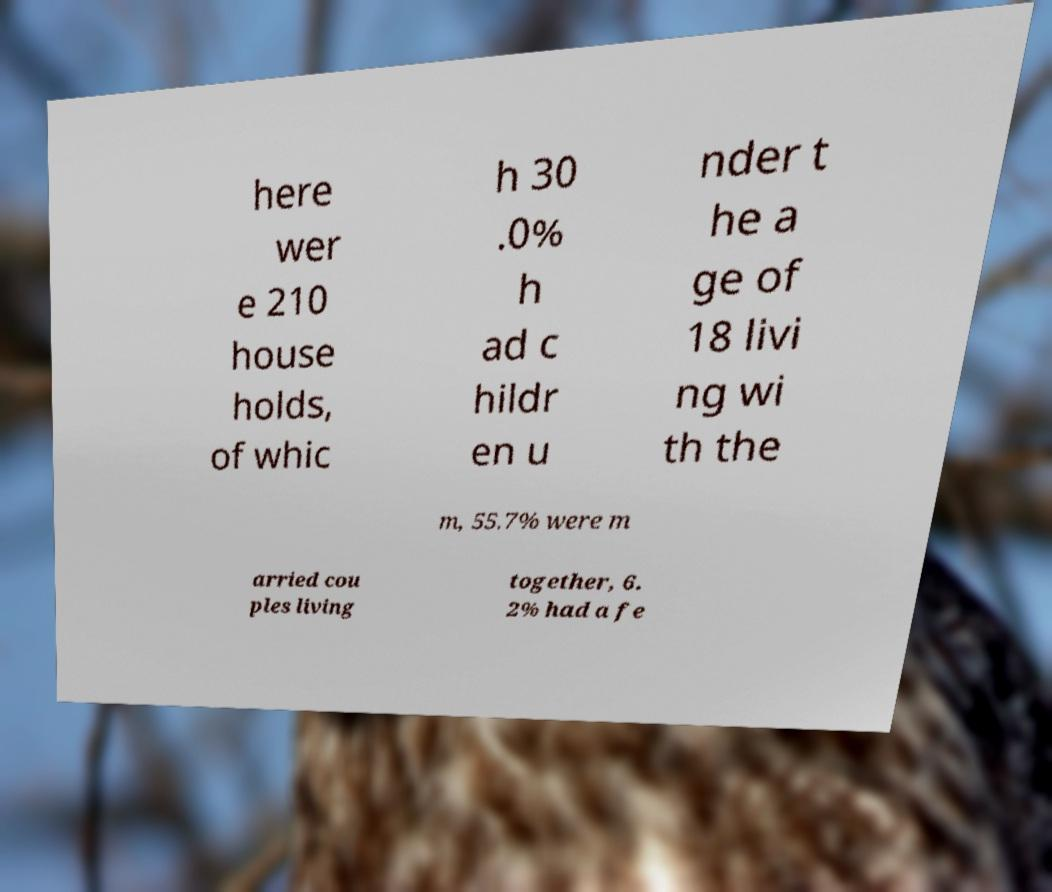Could you extract and type out the text from this image? here wer e 210 house holds, of whic h 30 .0% h ad c hildr en u nder t he a ge of 18 livi ng wi th the m, 55.7% were m arried cou ples living together, 6. 2% had a fe 